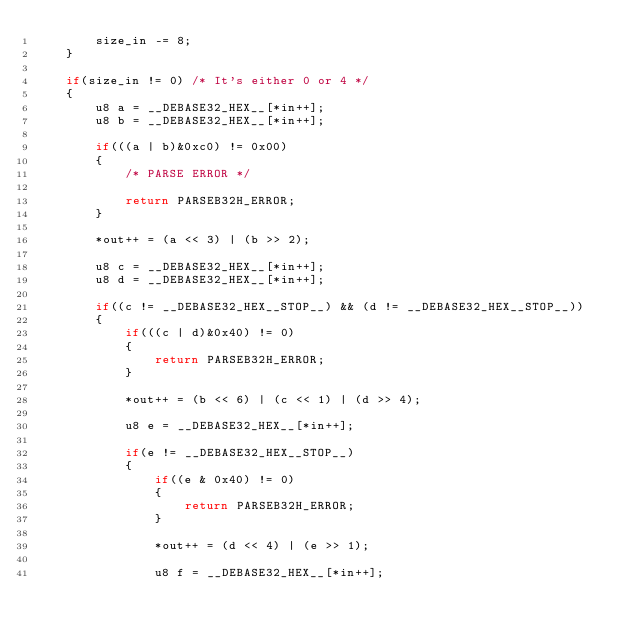<code> <loc_0><loc_0><loc_500><loc_500><_C_>        size_in -= 8;
    }

    if(size_in != 0) /* It's either 0 or 4 */
    {
        u8 a = __DEBASE32_HEX__[*in++];
        u8 b = __DEBASE32_HEX__[*in++];

        if(((a | b)&0xc0) != 0x00)
        {
            /* PARSE ERROR */

            return PARSEB32H_ERROR;
        }

        *out++ = (a << 3) | (b >> 2);

        u8 c = __DEBASE32_HEX__[*in++];
        u8 d = __DEBASE32_HEX__[*in++];

        if((c != __DEBASE32_HEX__STOP__) && (d != __DEBASE32_HEX__STOP__))
        {
            if(((c | d)&0x40) != 0)
            {
                return PARSEB32H_ERROR;
            }

            *out++ = (b << 6) | (c << 1) | (d >> 4);

            u8 e = __DEBASE32_HEX__[*in++];

            if(e != __DEBASE32_HEX__STOP__)
            {
                if((e & 0x40) != 0)
                {
                    return PARSEB32H_ERROR;
                }

                *out++ = (d << 4) | (e >> 1);

                u8 f = __DEBASE32_HEX__[*in++];</code> 